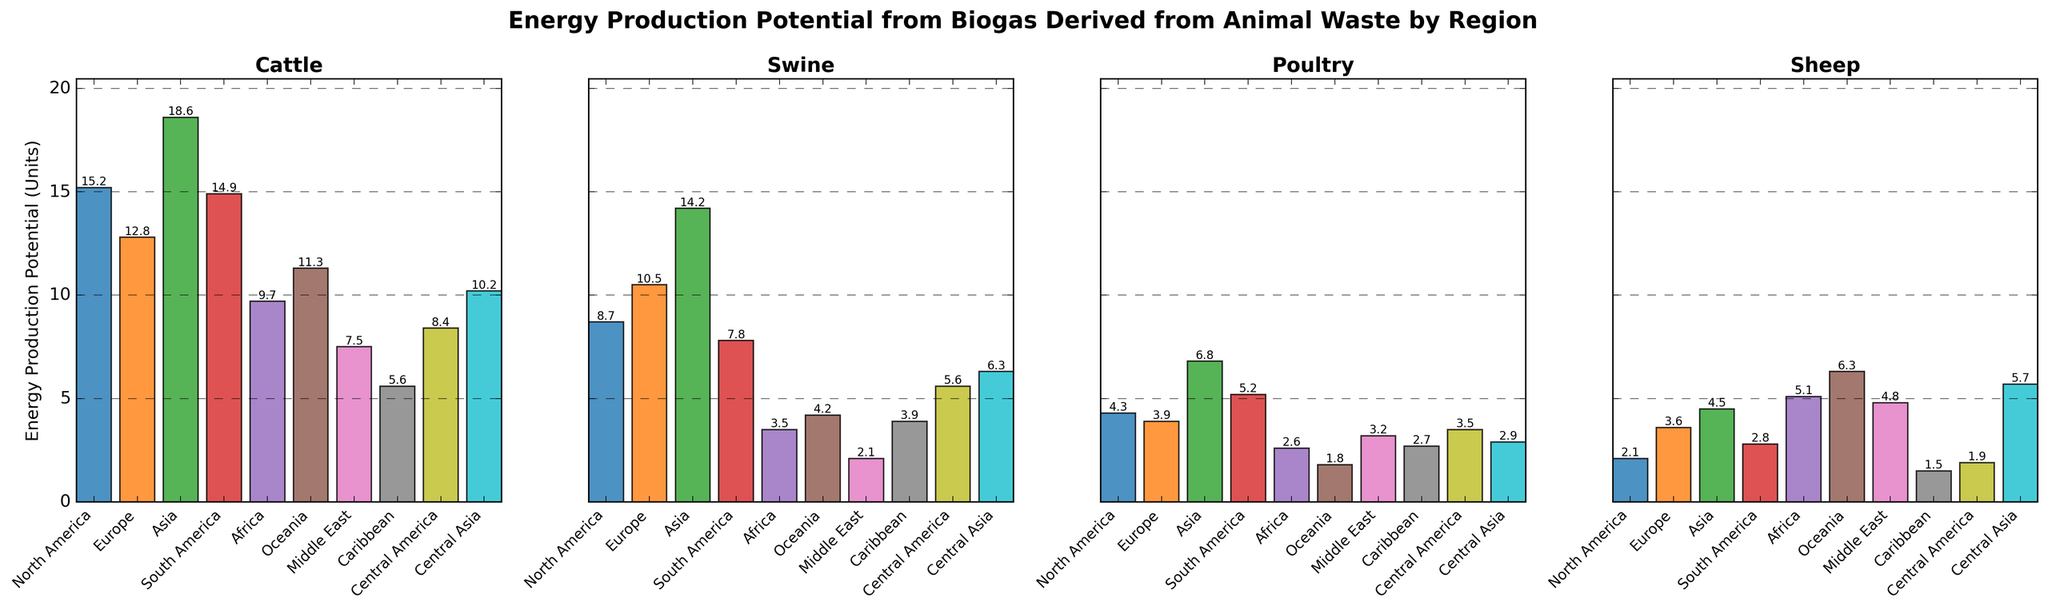What region has the highest energy production potential from poultry waste? Compare the heights of the bars representing poultry waste across all regions. Asia has the highest bar for poultry.
Answer: Asia What is the average energy production potential across all regions for cattle and swine combined? Sum the values for cattle and swine for each region, then calculate the average. (15.2+12.8+18.6+14.9+9.7+11.3+7.5+5.6+8.4+10.2) + (8.7+10.5+14.2+7.8+3.5+4.2+2.1+3.9+5.6+6.3) = 114.2 + 66.8 = 181.0. Average = 181.0 / 10 = 18.1.
Answer: 18.1 Which region has a higher energy production potential from sheep waste, Oceania or Central Asia? Compare the heights of the bars representing sheep waste for Oceania and Central Asia. Central Asia has a higher bar than Oceania.
Answer: Central Asia In which region is the energy production potential from biogas derived from cattle waste equal to that of biogas derived from swine waste? Look for regions where the heights of bars representing cattle and swine waste are equal. No such region has equal values.
Answer: None What is the total energy production potential from all animal wastes for Europe? Sum the values for cattle, swine, poultry, and sheep for Europe. 12.8 + 10.5 + 3.9 + 3.6 = 30.8.
Answer: 30.8 How much greater is the energy production potential from biogas derived from cattle waste in Asia compared to North America? Subtract the value of cattle waste in North America from the value in Asia. 18.6 - 15.2 = 3.4.
Answer: 3.4 Which animal waste contributes the least to energy production potential in the Middle East? Compare the heights of the bars representing each type of animal waste in the Middle East. Swine has the smallest bar.
Answer: Swine In which region is the difference between energy production potentials from poultry and sheep waste the greatest? Calculate the absolute difference between poultry and sheep waste for each region and find the maximum. Asia: 6.8 - 4.5 = 2.3, North America: 4.3 - 2.1 = 2.2, and so on. South America: 5.2 - 2.8 = 2.4. The greatest difference is in South America.
Answer: South America 